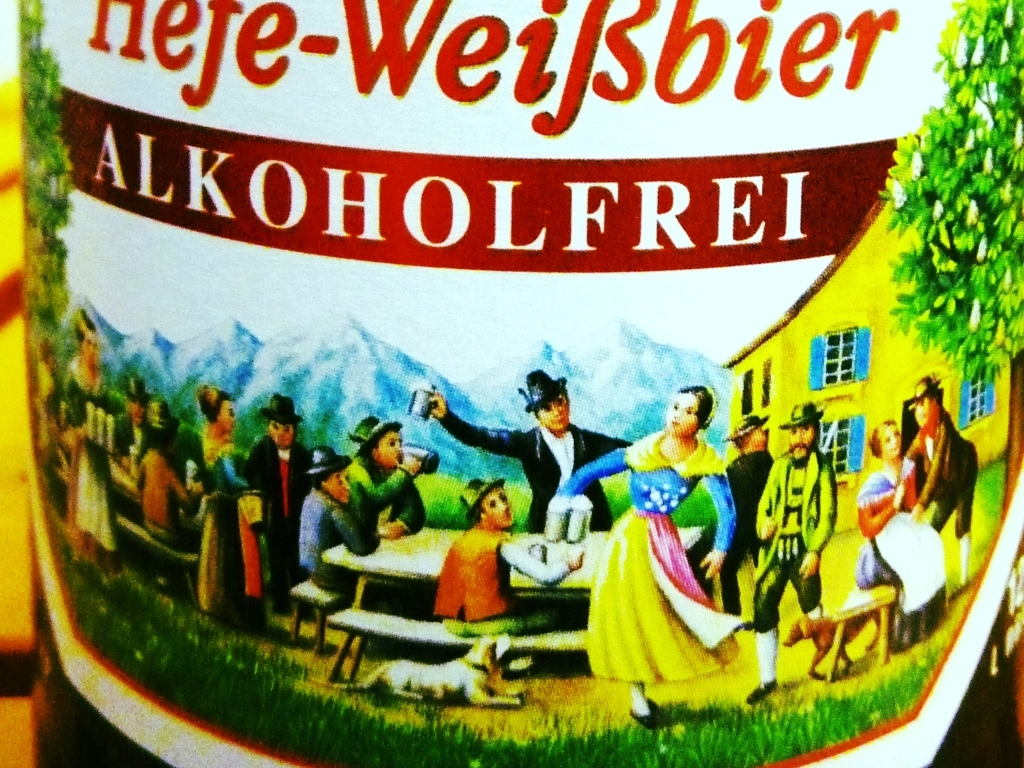Could you tell me more about the cultural significance of the scene depicted in the image? Certainly, the festive gathering illustrated in the image is evocative of communal beer culture in Germany, particularly in regions like Bavaria. Such scenes are symbolic of Gemütlichkeit, a term describing a state of warmth, friendliness, and good cheer. Traditional outfits, like dirndls and lederhosen, emphasize the cultural heritage. Beer gardens, where people come together to enjoy beer, food, and companionship, are an integral part of this tradition, highlighting the social aspect of German beer-drinking customs. 